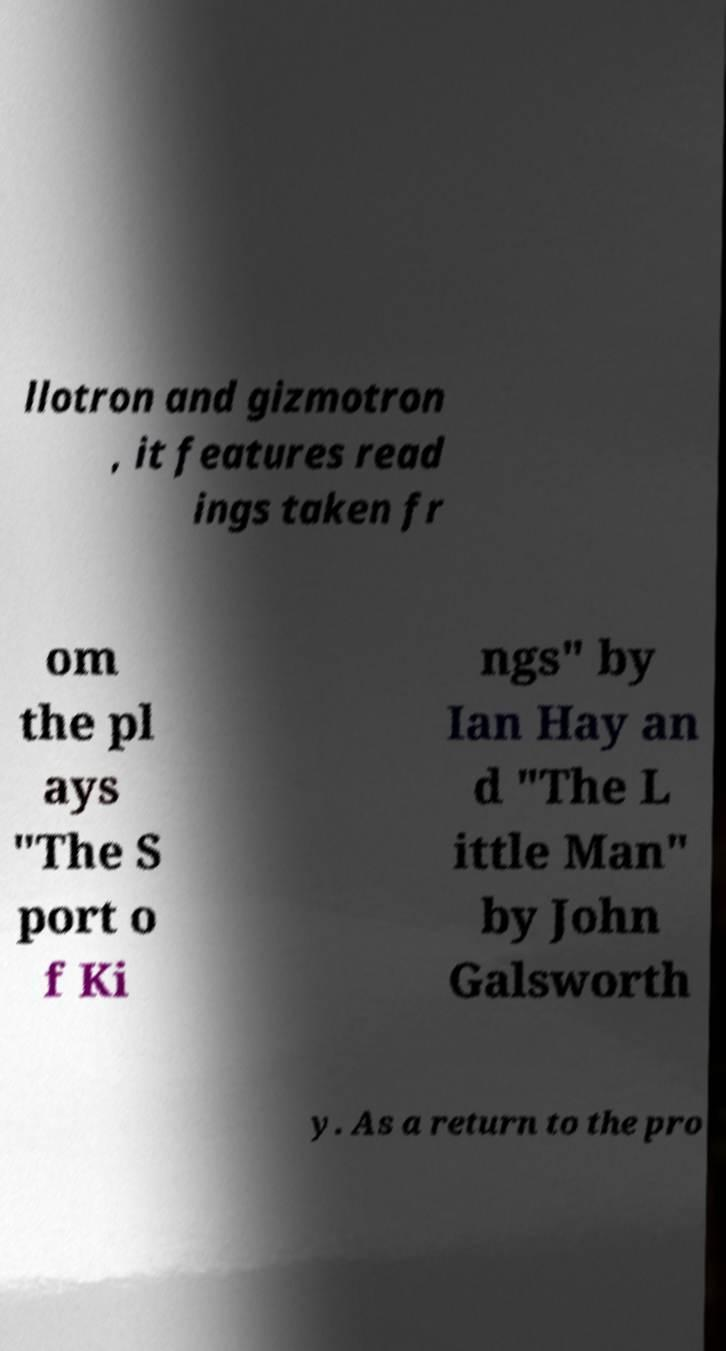I need the written content from this picture converted into text. Can you do that? llotron and gizmotron , it features read ings taken fr om the pl ays "The S port o f Ki ngs" by Ian Hay an d "The L ittle Man" by John Galsworth y. As a return to the pro 